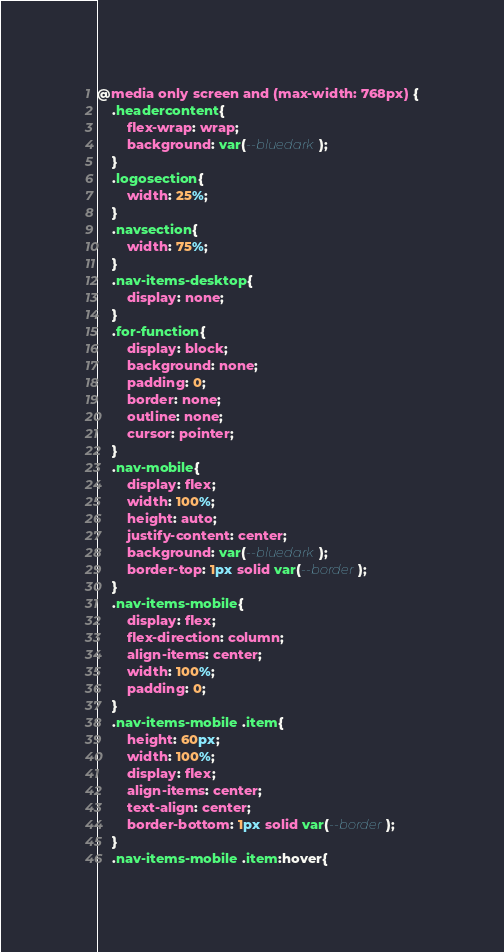Convert code to text. <code><loc_0><loc_0><loc_500><loc_500><_CSS_>
@media only screen and (max-width: 768px) {
    .headercontent{
        flex-wrap: wrap;
        background: var(--bluedark);
    }
    .logosection{
        width: 25%;
    }
    .navsection{
        width: 75%;
    }
    .nav-items-desktop{
        display: none;
    }
    .for-function{
        display: block;
        background: none;
        padding: 0;
        border: none;
        outline: none;
        cursor: pointer;
    }
    .nav-mobile{
        display: flex;
        width: 100%;
        height: auto;
        justify-content: center;
        background: var(--bluedark);
        border-top: 1px solid var(--border);
    }
    .nav-items-mobile{
        display: flex;
        flex-direction: column;
        align-items: center;
        width: 100%;
        padding: 0;
    }
    .nav-items-mobile .item{
        height: 60px;
        width: 100%;
        display: flex;
        align-items: center;
        text-align: center;
        border-bottom: 1px solid var(--border);
    }
    .nav-items-mobile .item:hover{</code> 